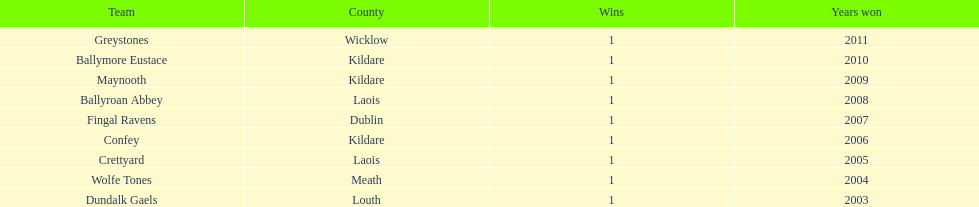Which is the first team from the chart Greystones. 